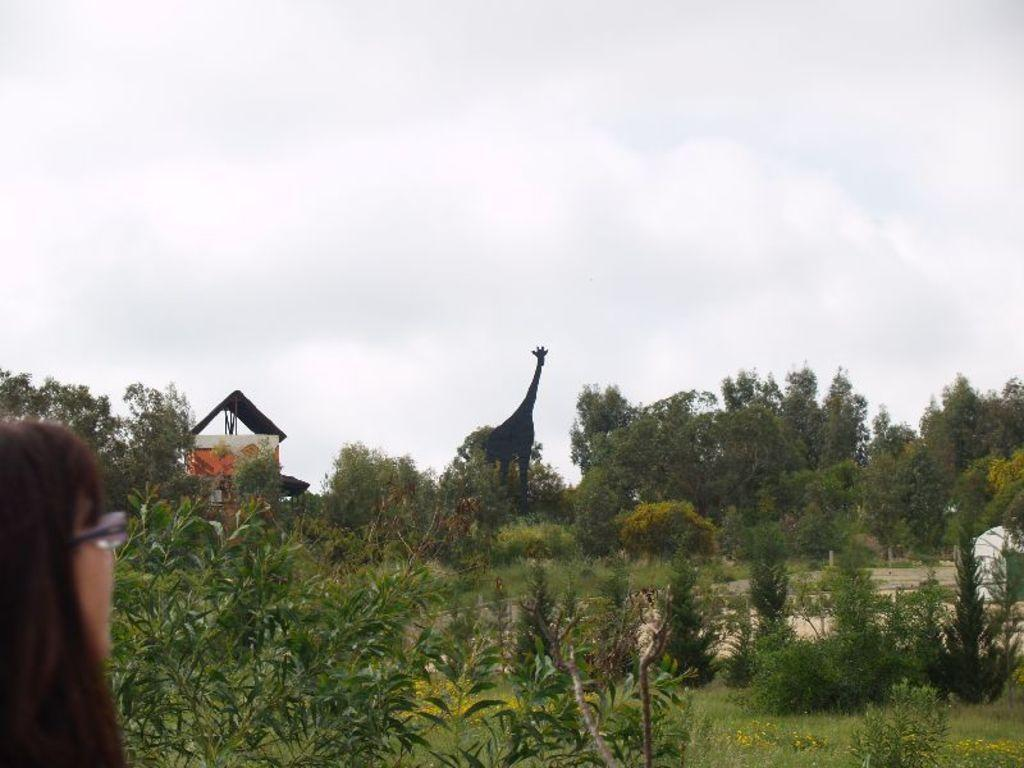What is the person in the image wearing? The person in the image is wearing spectacles. What type of vegetation can be seen in the image? There are plants, grass, and trees in the image. What type of structure is visible in the image? There is a house in the image. What animal is present in the image? There is a giraffe in the image. What is visible in the background of the image? The sky is visible in the background of the image. What date is marked on the calendar in the image? There is no calendar present in the image. How many visitors are visible in the image? There is no visitor present in the image. 